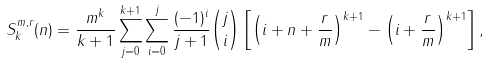Convert formula to latex. <formula><loc_0><loc_0><loc_500><loc_500>S _ { k } ^ { m , r } ( n ) = \frac { m ^ { k } } { k + 1 } \sum _ { j = 0 } ^ { k + 1 } \sum _ { i = 0 } ^ { j } \frac { ( - 1 ) ^ { i } } { j + 1 } \binom { j } { i } \left [ \left ( i + n + \frac { r } { m } \right ) ^ { k + 1 } - \left ( i + \frac { r } { m } \right ) ^ { k + 1 } \right ] ,</formula> 